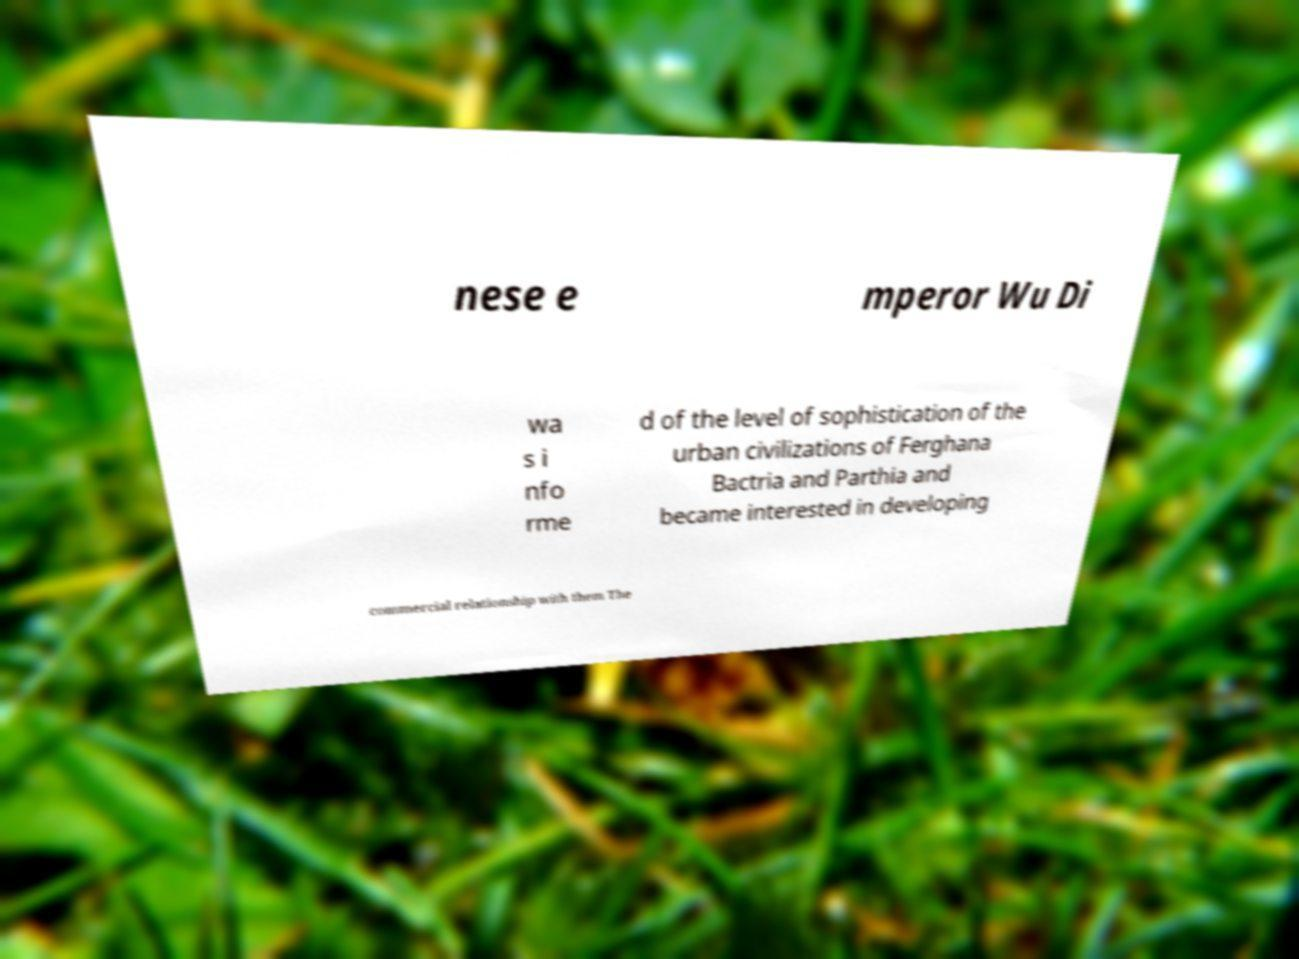Can you accurately transcribe the text from the provided image for me? nese e mperor Wu Di wa s i nfo rme d of the level of sophistication of the urban civilizations of Ferghana Bactria and Parthia and became interested in developing commercial relationship with them The 